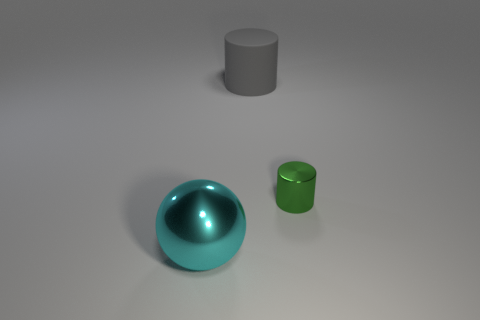Subtract all blue cylinders. Subtract all green balls. How many cylinders are left? 2 Add 1 cyan objects. How many objects exist? 4 Subtract all cylinders. How many objects are left? 1 Subtract all yellow matte things. Subtract all balls. How many objects are left? 2 Add 2 cyan metal spheres. How many cyan metal spheres are left? 3 Add 1 big gray rubber cylinders. How many big gray rubber cylinders exist? 2 Subtract 0 gray blocks. How many objects are left? 3 